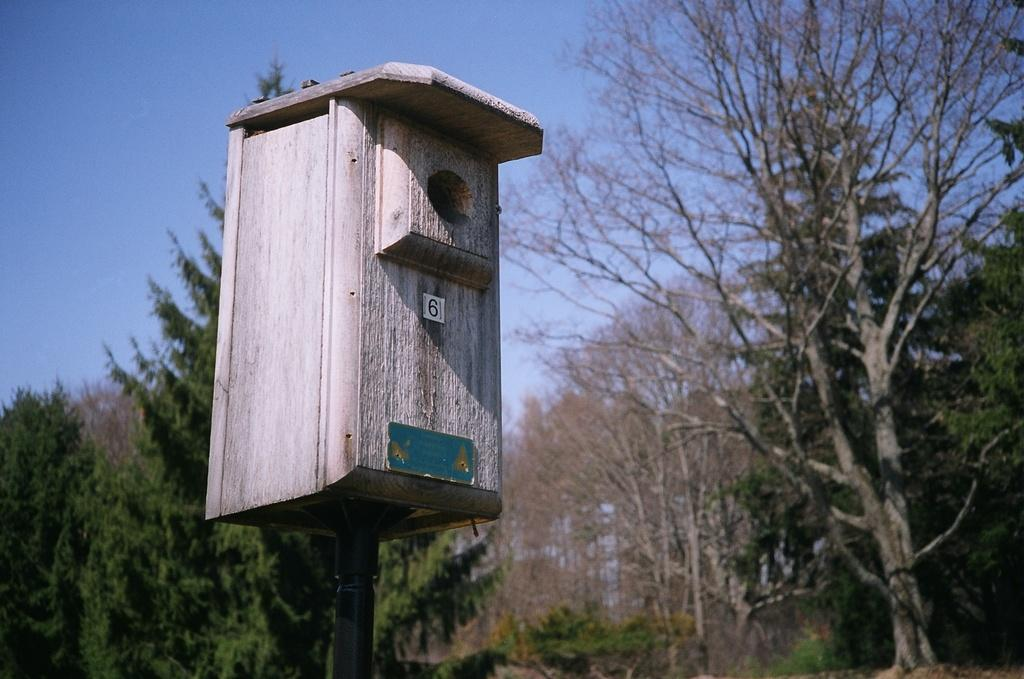What is the wooden object attached to in the image? The wooden object is attached to a pole in the image. What can be seen in the background of the image? There are trees in the background of the image. What is the color of the trees? The trees are green. What is the color of the sky in the image? The sky is blue. What type of celery is being used as a religious symbol in the image? There is no celery present in the image, and no religious symbols are depicted. 